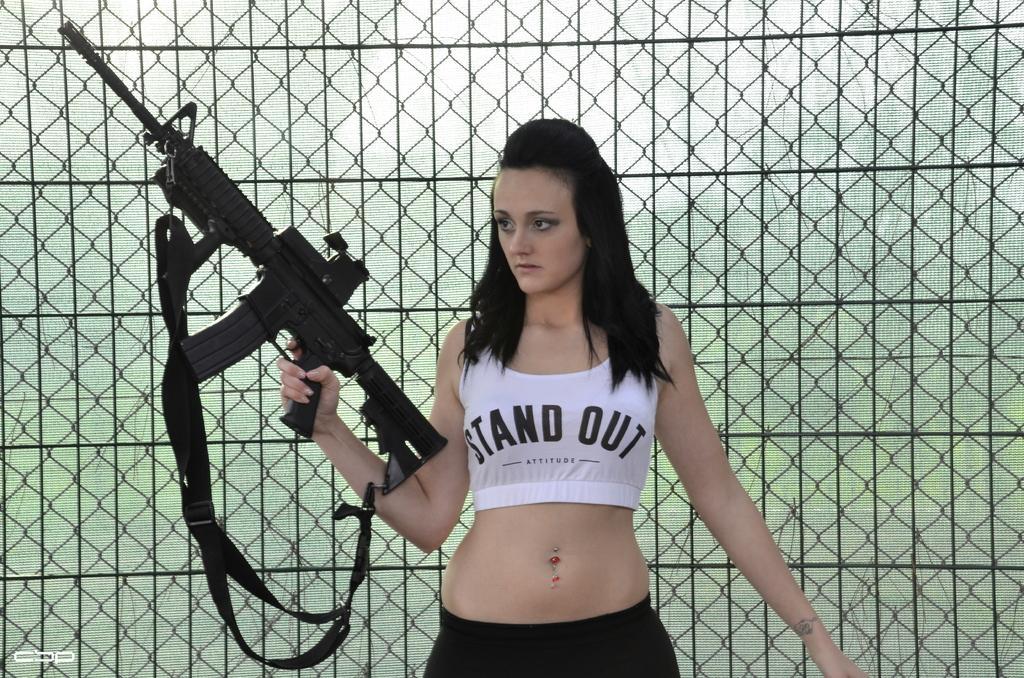Please provide a concise description of this image. In the center of the picture we can see a woman holding a gun, behind her there is fencing. 